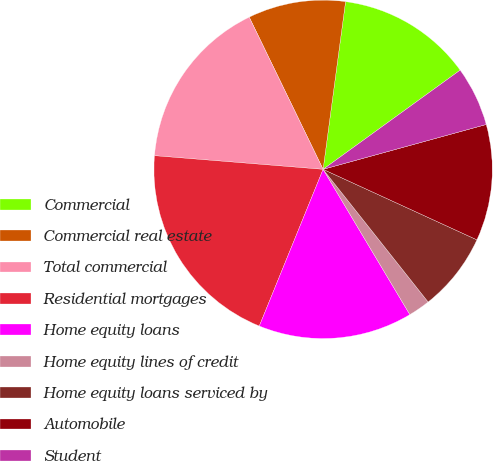<chart> <loc_0><loc_0><loc_500><loc_500><pie_chart><fcel>Commercial<fcel>Commercial real estate<fcel>Total commercial<fcel>Residential mortgages<fcel>Home equity loans<fcel>Home equity lines of credit<fcel>Home equity loans serviced by<fcel>Automobile<fcel>Student<nl><fcel>12.91%<fcel>9.31%<fcel>16.52%<fcel>20.13%<fcel>14.72%<fcel>2.09%<fcel>7.5%<fcel>11.11%<fcel>5.7%<nl></chart> 